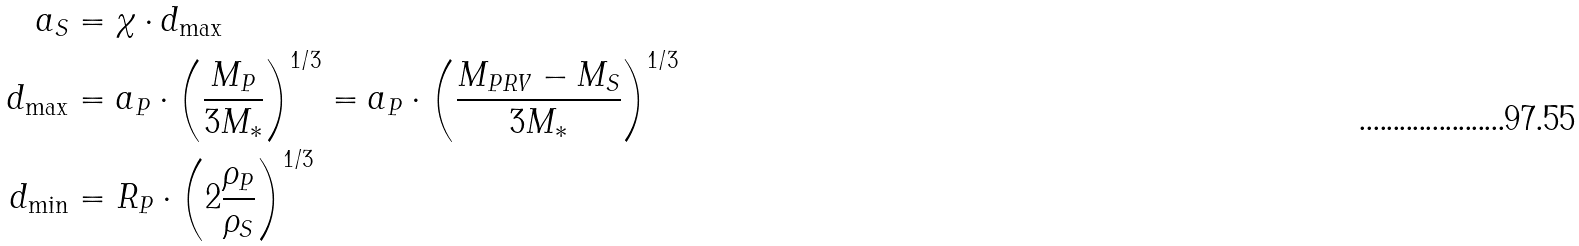Convert formula to latex. <formula><loc_0><loc_0><loc_500><loc_500>a _ { S } & = \chi \cdot d _ { \max } \\ d _ { \max } & = a _ { P } \cdot \left ( \frac { M _ { P } } { 3 M _ { * } } \right ) ^ { 1 / 3 } = a _ { P } \cdot \left ( \frac { M _ { P R V } - M _ { S } } { 3 M _ { * } } \right ) ^ { 1 / 3 } \\ d _ { \min } & = R _ { P } \cdot \left ( 2 \frac { \rho _ { P } } { \rho _ { S } } \right ) ^ { 1 / 3 }</formula> 